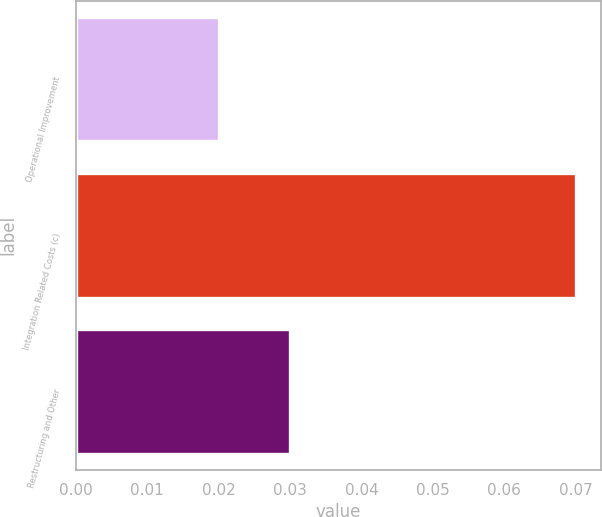Convert chart. <chart><loc_0><loc_0><loc_500><loc_500><bar_chart><fcel>Operational Improvement<fcel>Integration Related Costs (c)<fcel>Restructuring and Other<nl><fcel>0.02<fcel>0.07<fcel>0.03<nl></chart> 